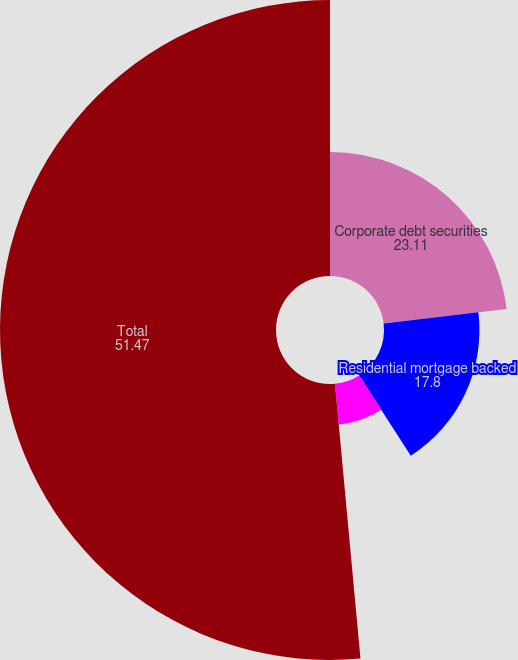Convert chart to OTSL. <chart><loc_0><loc_0><loc_500><loc_500><pie_chart><fcel>Corporate debt securities<fcel>Residential mortgage backed<fcel>Asset backed securities<fcel>Total<nl><fcel>23.11%<fcel>17.8%<fcel>7.62%<fcel>51.47%<nl></chart> 